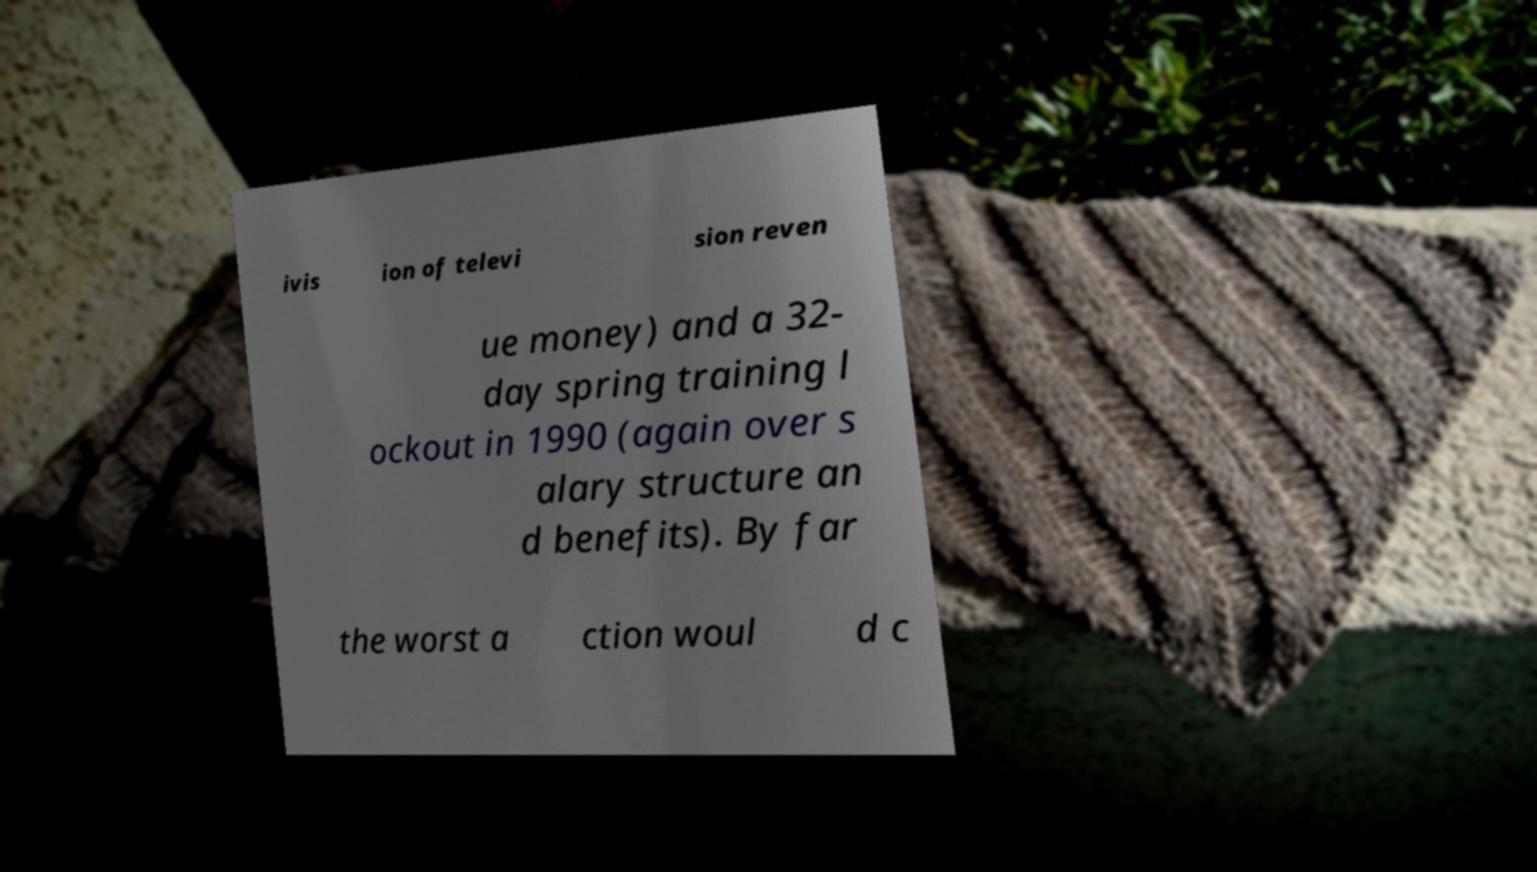I need the written content from this picture converted into text. Can you do that? ivis ion of televi sion reven ue money) and a 32- day spring training l ockout in 1990 (again over s alary structure an d benefits). By far the worst a ction woul d c 